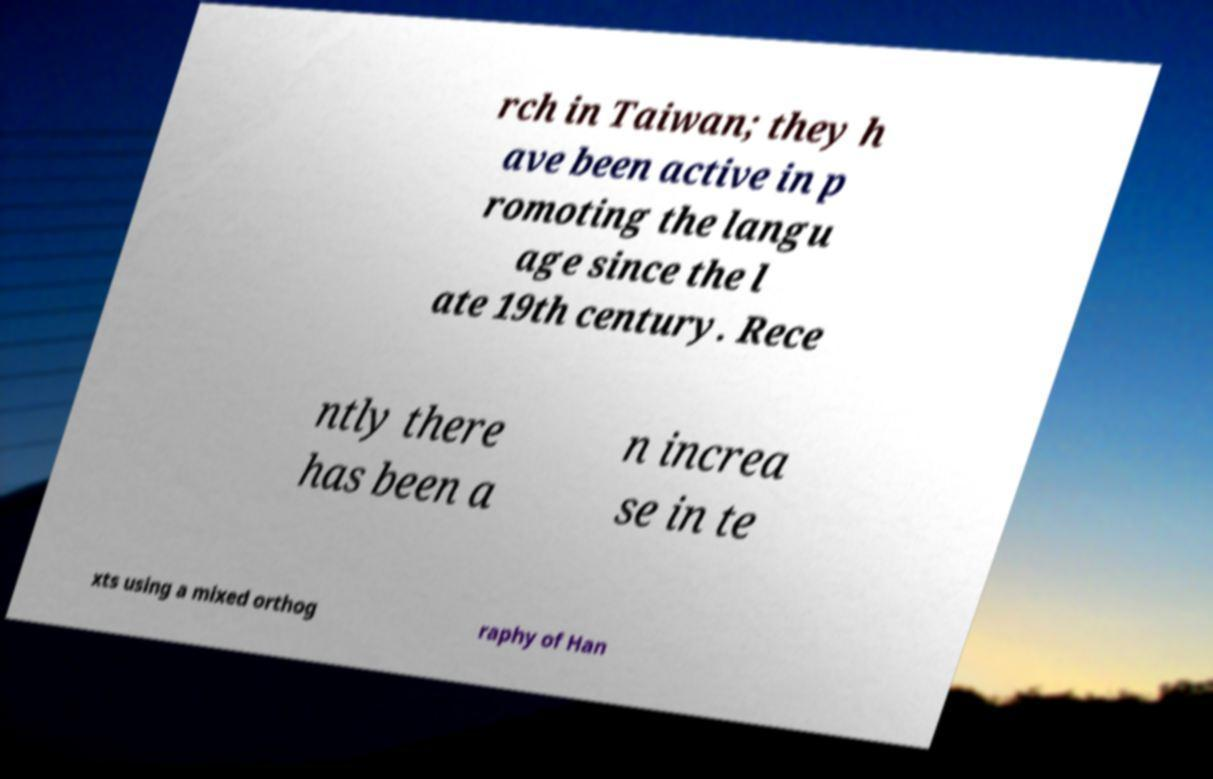For documentation purposes, I need the text within this image transcribed. Could you provide that? rch in Taiwan; they h ave been active in p romoting the langu age since the l ate 19th century. Rece ntly there has been a n increa se in te xts using a mixed orthog raphy of Han 